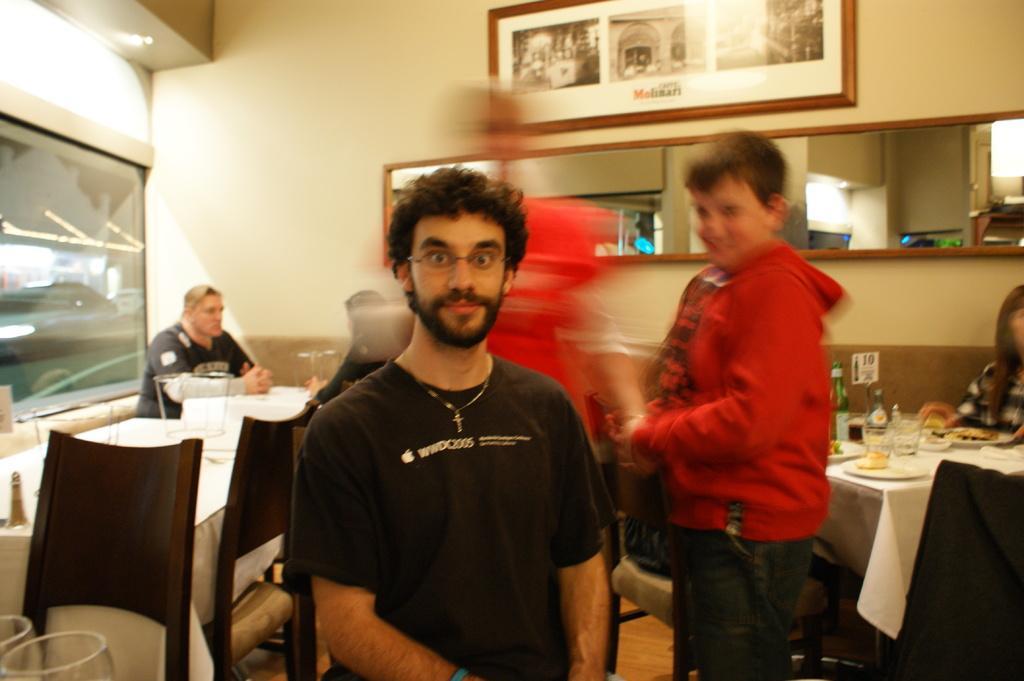In one or two sentences, can you explain what this image depicts? In this image we can see a few people, some of them are sitting on the chairs, there are tables, there are bottles, glasses, food items on the plates, there is a photo frame on the wall, there is a window, and a mirror. 